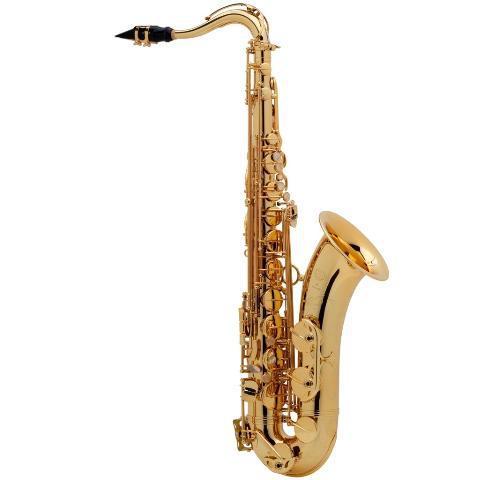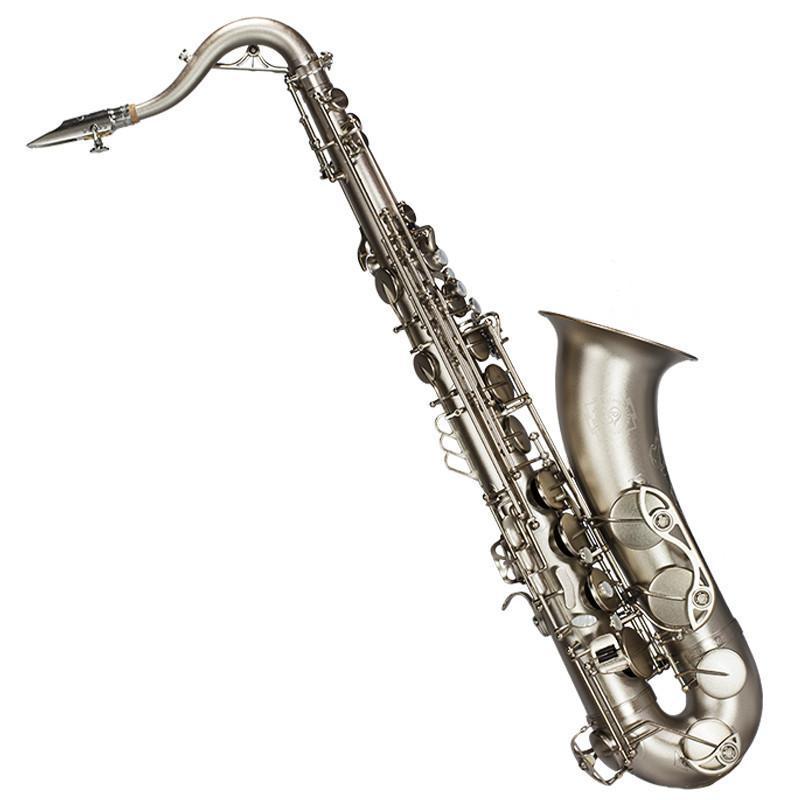The first image is the image on the left, the second image is the image on the right. Considering the images on both sides, is "A gold-colored right-facing saxophone is displayed fully upright on a black background." valid? Answer yes or no. No. The first image is the image on the left, the second image is the image on the right. Evaluate the accuracy of this statement regarding the images: "The full length of two saxophones are shown, each of them a different color, but both with a mouthpiece of the same shape.". Is it true? Answer yes or no. Yes. 